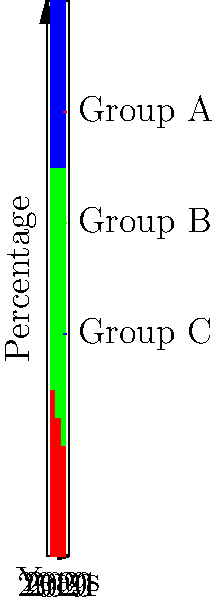As an employee at the Centre for Policy Alternatives, you are analyzing demographic trends over the past three years. The stacked bar chart shows the proportion of three demographic groups (A, B, and C) from 2019 to 2021. Which group has shown the most significant increase in its proportion over this period? To determine which group has shown the most significant increase in proportion, we need to compare the changes for each group from 2019 to 2021:

1. Group A (red):
   2019: 30%
   2021: 20%
   Change: -10% (decrease)

2. Group B (green):
   2019: 40%
   2021: 50%
   Change: +10% (increase)

3. Group C (blue):
   2019: 30%
   2021: 30%
   Change: 0% (no change)

Comparing these changes:
- Group A decreased by 10%
- Group B increased by 10%
- Group C remained constant

Therefore, Group B has shown the most significant increase in its proportion over the three-year period.
Answer: Group B 